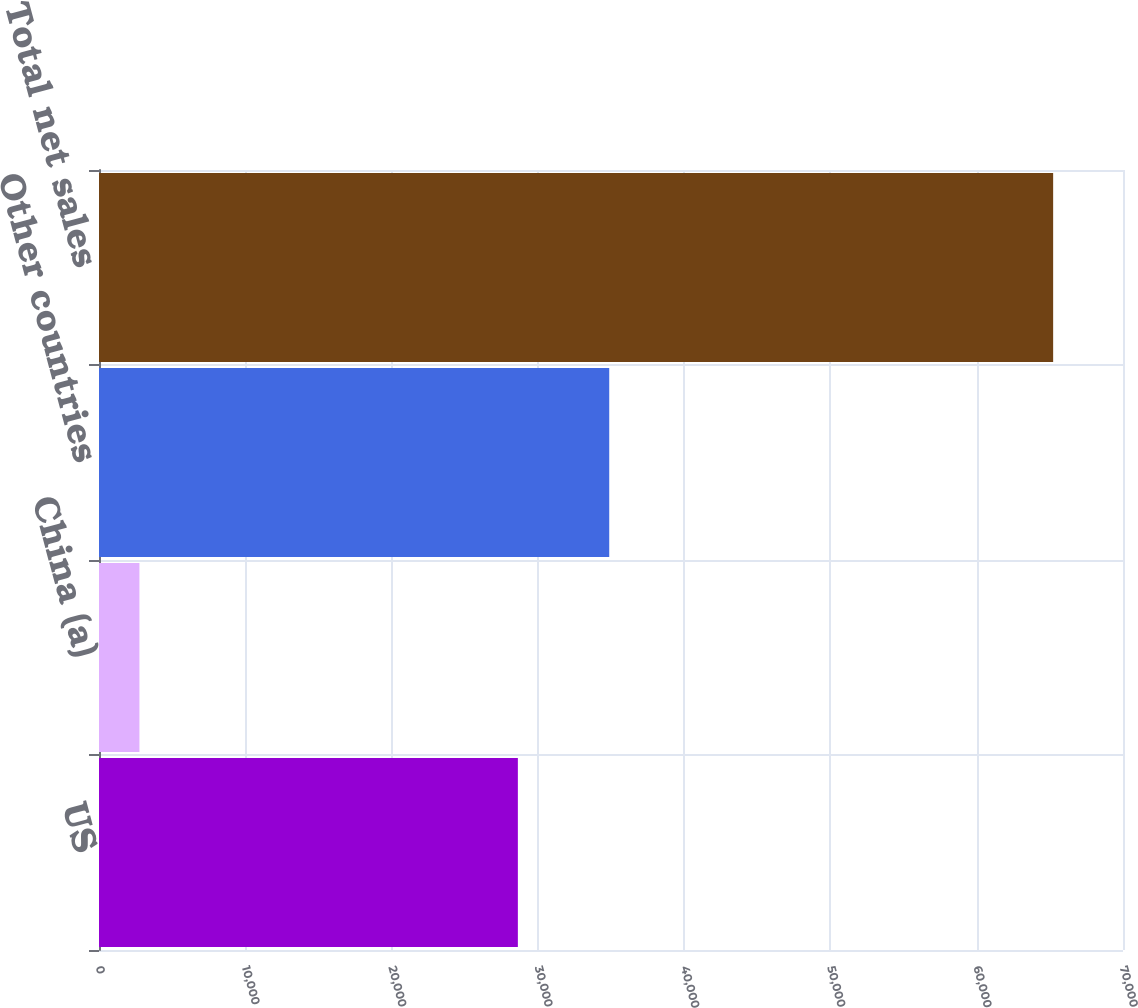<chart> <loc_0><loc_0><loc_500><loc_500><bar_chart><fcel>US<fcel>China (a)<fcel>Other countries<fcel>Total net sales<nl><fcel>28633<fcel>2764<fcel>34879.1<fcel>65225<nl></chart> 